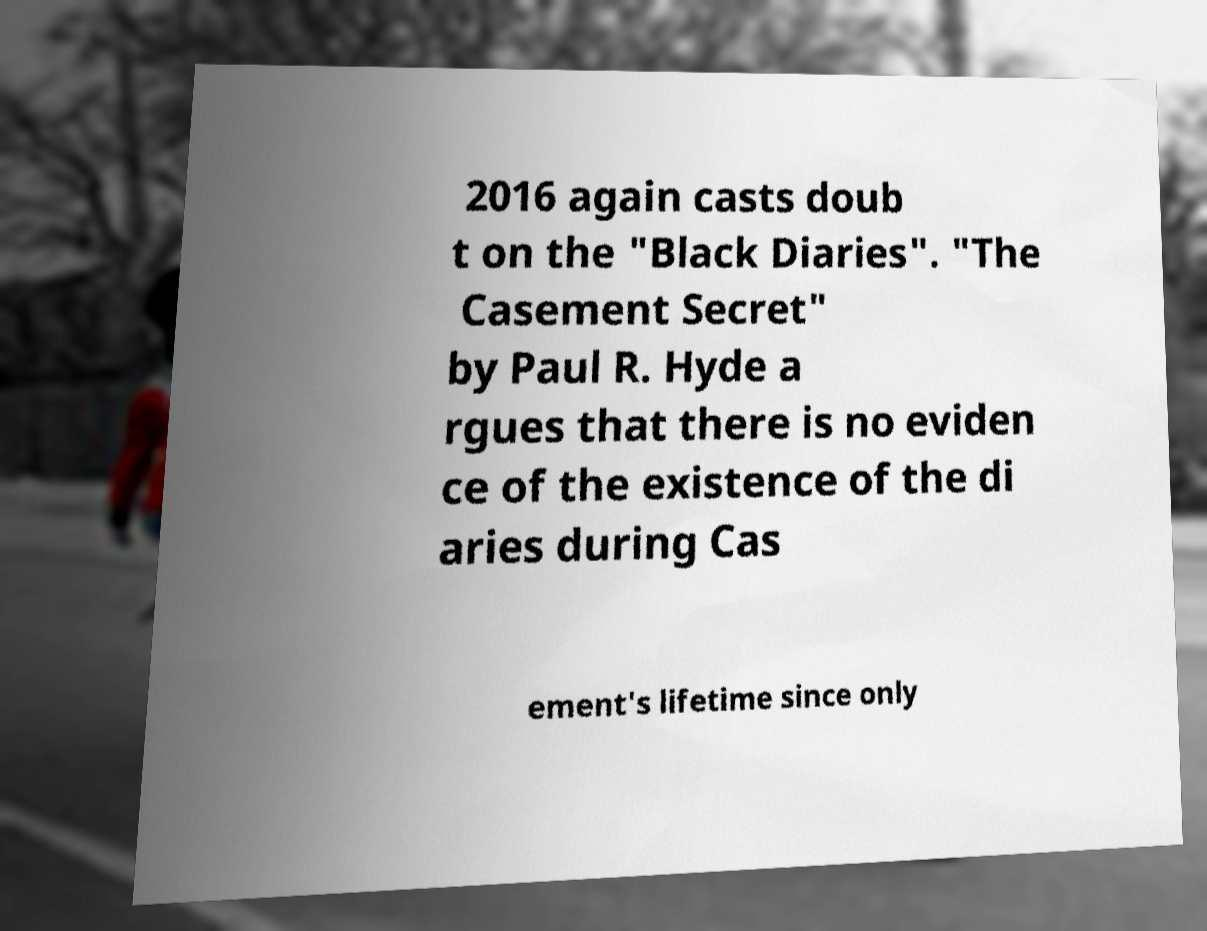Please identify and transcribe the text found in this image. 2016 again casts doub t on the "Black Diaries". "The Casement Secret" by Paul R. Hyde a rgues that there is no eviden ce of the existence of the di aries during Cas ement's lifetime since only 